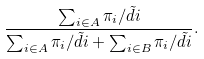<formula> <loc_0><loc_0><loc_500><loc_500>\frac { \sum _ { i \in A } \pi _ { i } / \tilde { d } i } { \sum _ { i \in A } \pi _ { i } / \tilde { d } i + \sum _ { i \in B } \pi _ { i } / \tilde { d } i } .</formula> 